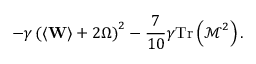Convert formula to latex. <formula><loc_0><loc_0><loc_500><loc_500>- \gamma \left ( \left \langle W \right \rangle + 2 \Omega \right ) ^ { 2 } - \frac { 7 } { 1 0 } \gamma T r \left ( \mathcal { M } ^ { 2 } \right ) .</formula> 